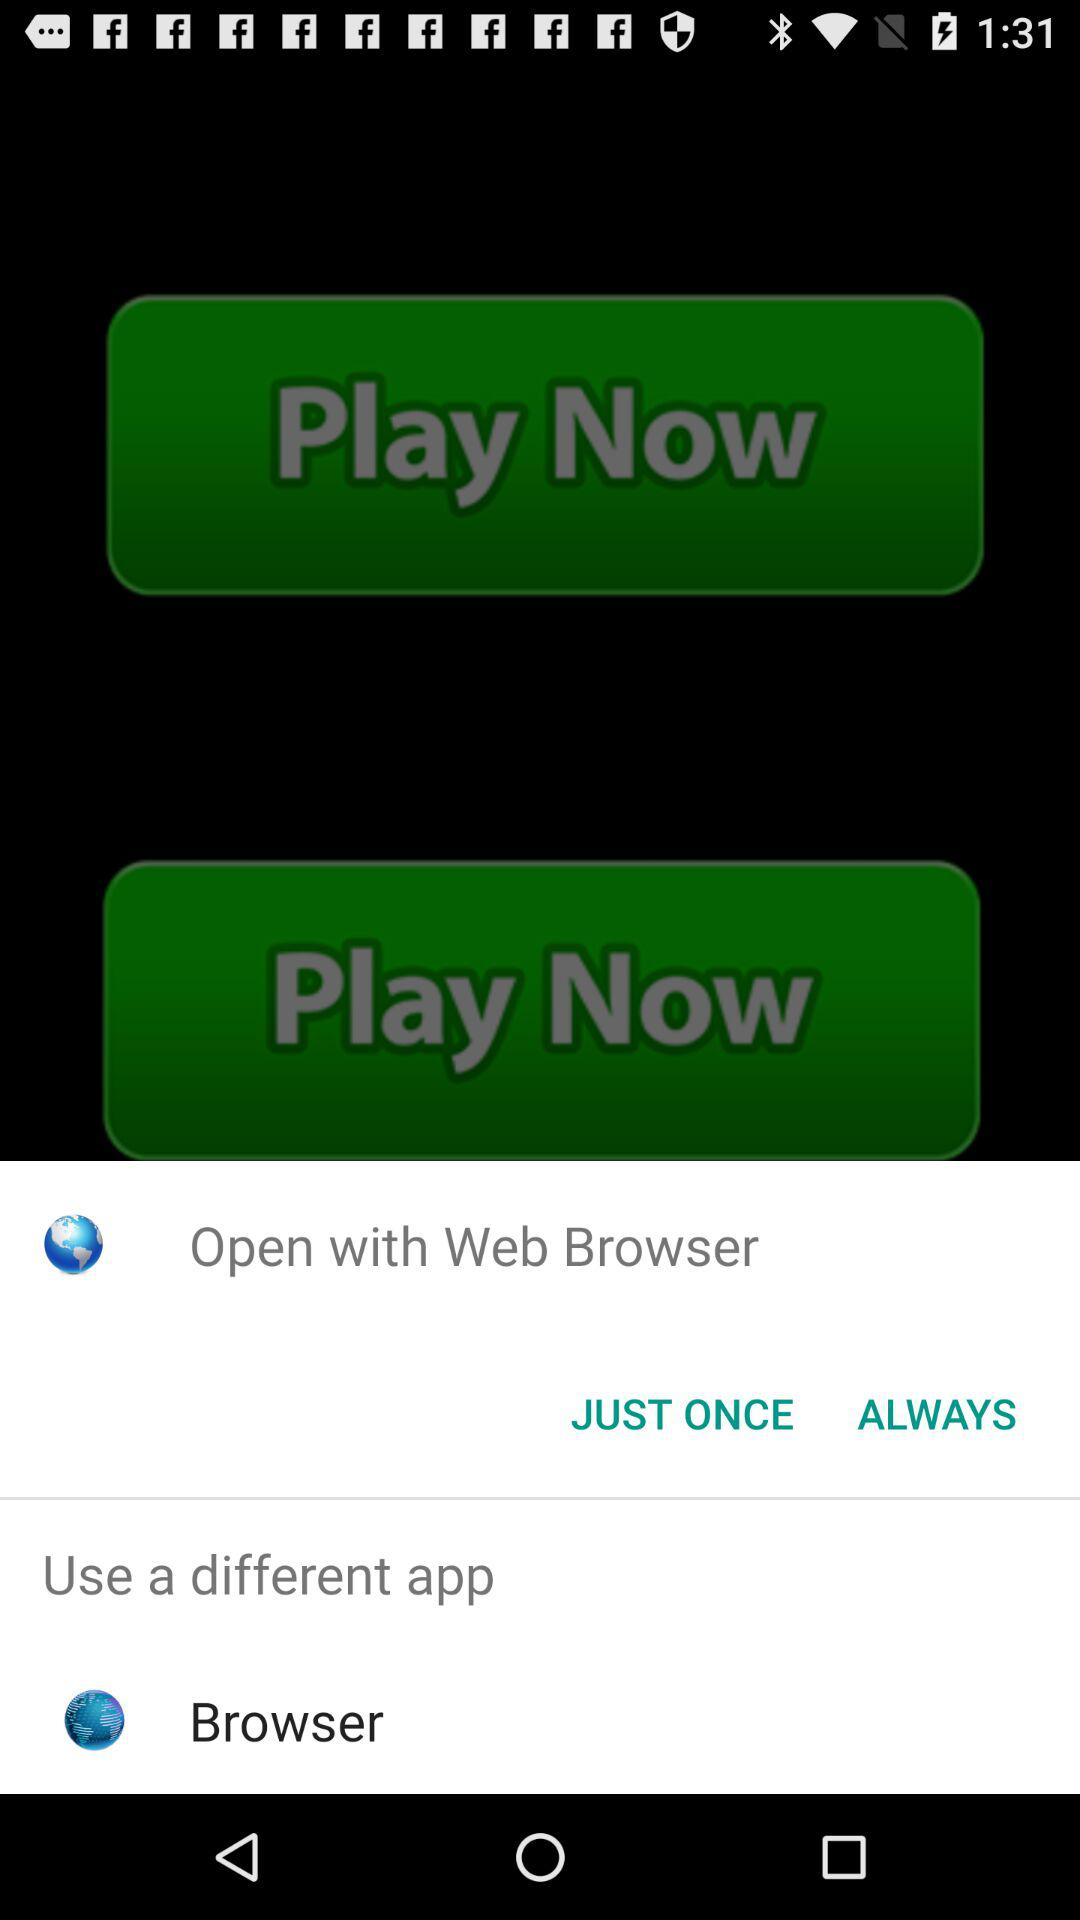What are the different apps I can use? The different app is "Browser". 